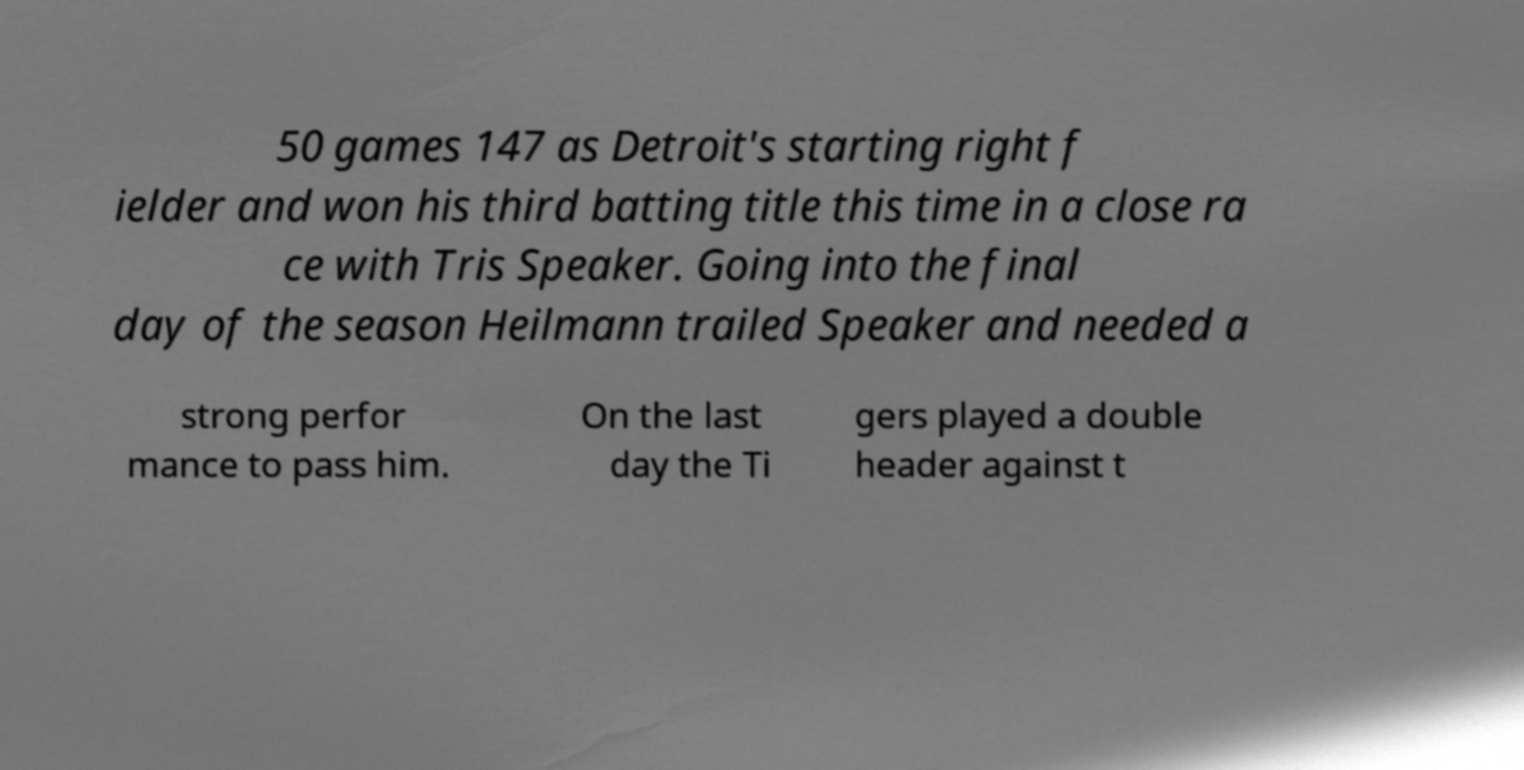Can you read and provide the text displayed in the image?This photo seems to have some interesting text. Can you extract and type it out for me? 50 games 147 as Detroit's starting right f ielder and won his third batting title this time in a close ra ce with Tris Speaker. Going into the final day of the season Heilmann trailed Speaker and needed a strong perfor mance to pass him. On the last day the Ti gers played a double header against t 